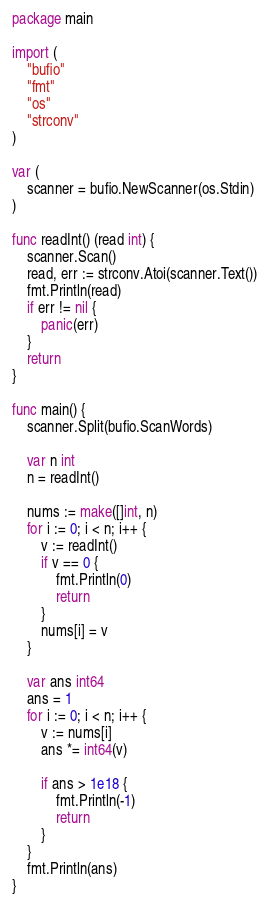<code> <loc_0><loc_0><loc_500><loc_500><_Go_>package main

import (
	"bufio"
	"fmt"
	"os"
	"strconv"
)

var (
	scanner = bufio.NewScanner(os.Stdin)
)

func readInt() (read int) {
	scanner.Scan()
	read, err := strconv.Atoi(scanner.Text())
	fmt.Println(read)
	if err != nil {
		panic(err)
	}
	return
}

func main() {
	scanner.Split(bufio.ScanWords)

	var n int
	n = readInt()

	nums := make([]int, n)
	for i := 0; i < n; i++ {
		v := readInt()
		if v == 0 {
			fmt.Println(0)
			return
		}
		nums[i] = v
	}

	var ans int64
	ans = 1
	for i := 0; i < n; i++ {
		v := nums[i]
		ans *= int64(v)

		if ans > 1e18 {
			fmt.Println(-1)
			return
		}
	}
	fmt.Println(ans)
}
</code> 